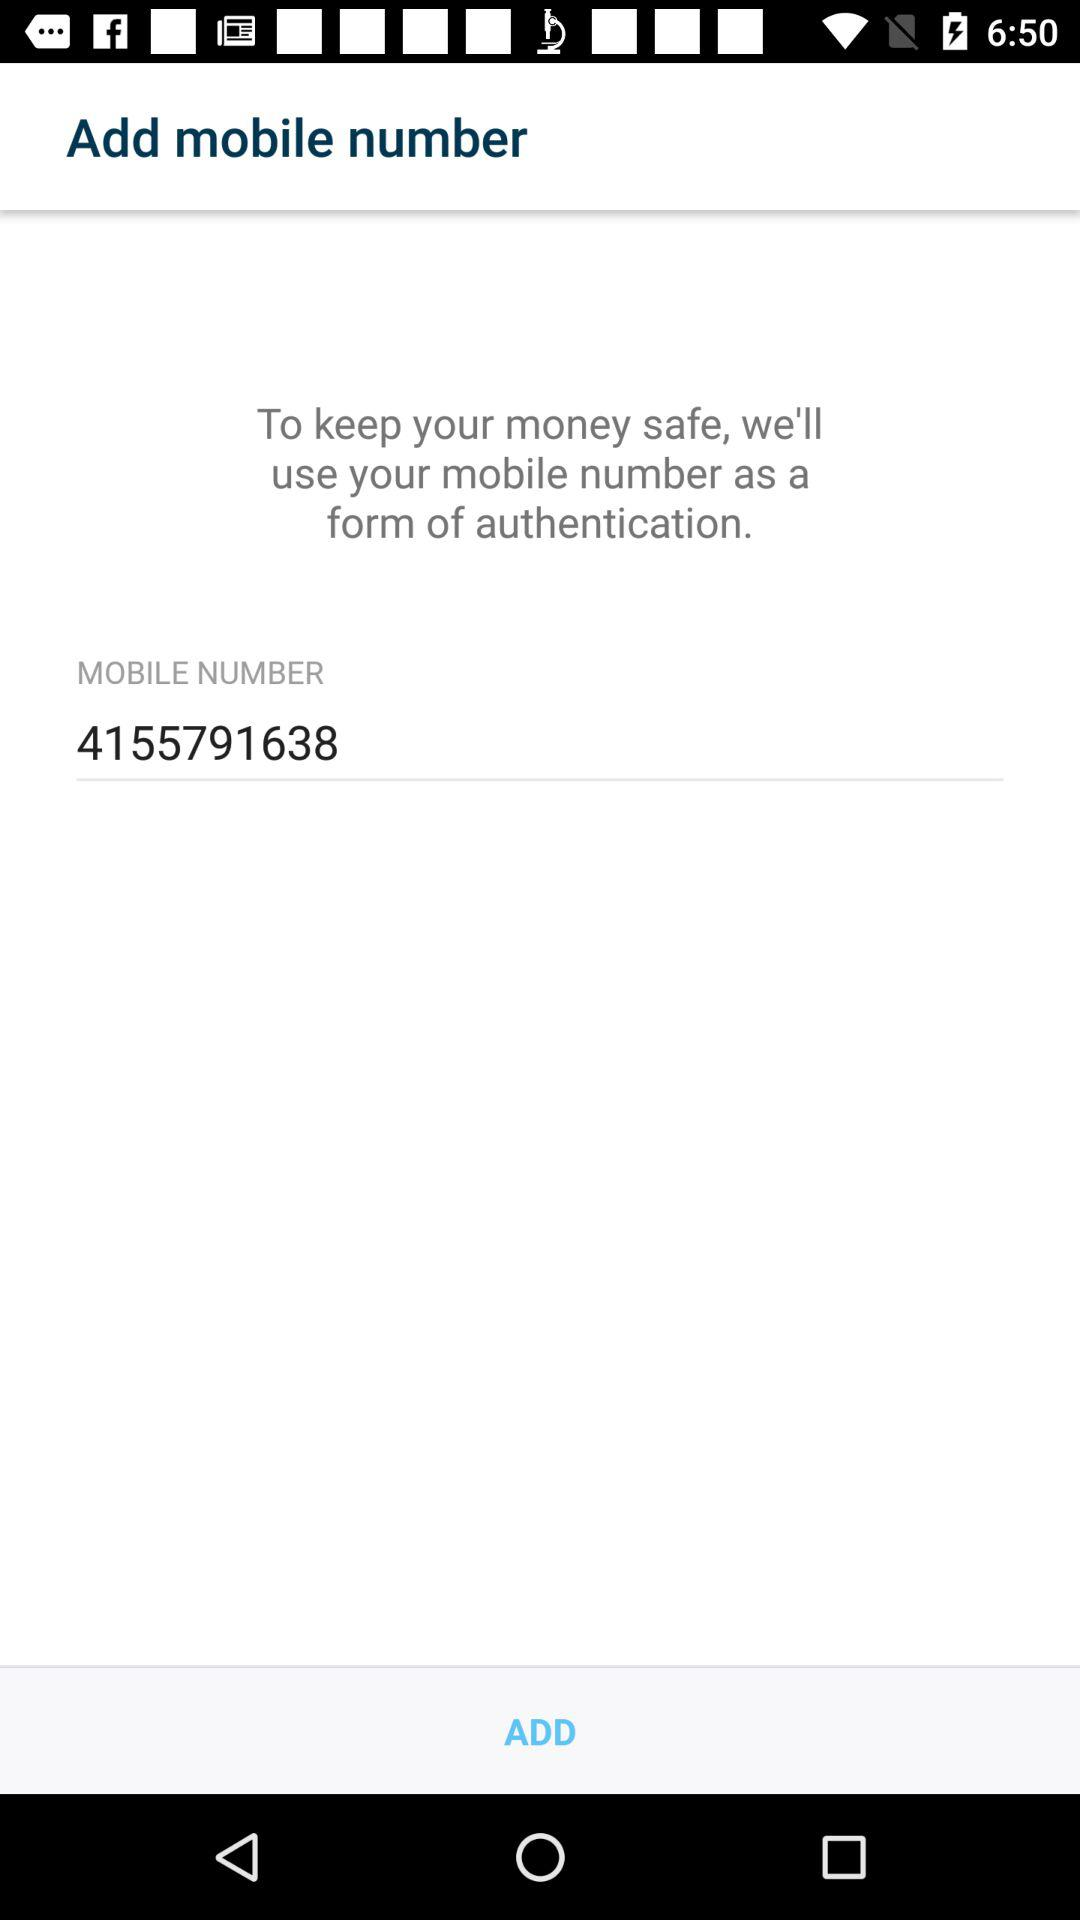What is the mobile number? The mobile number is 4155791638. 